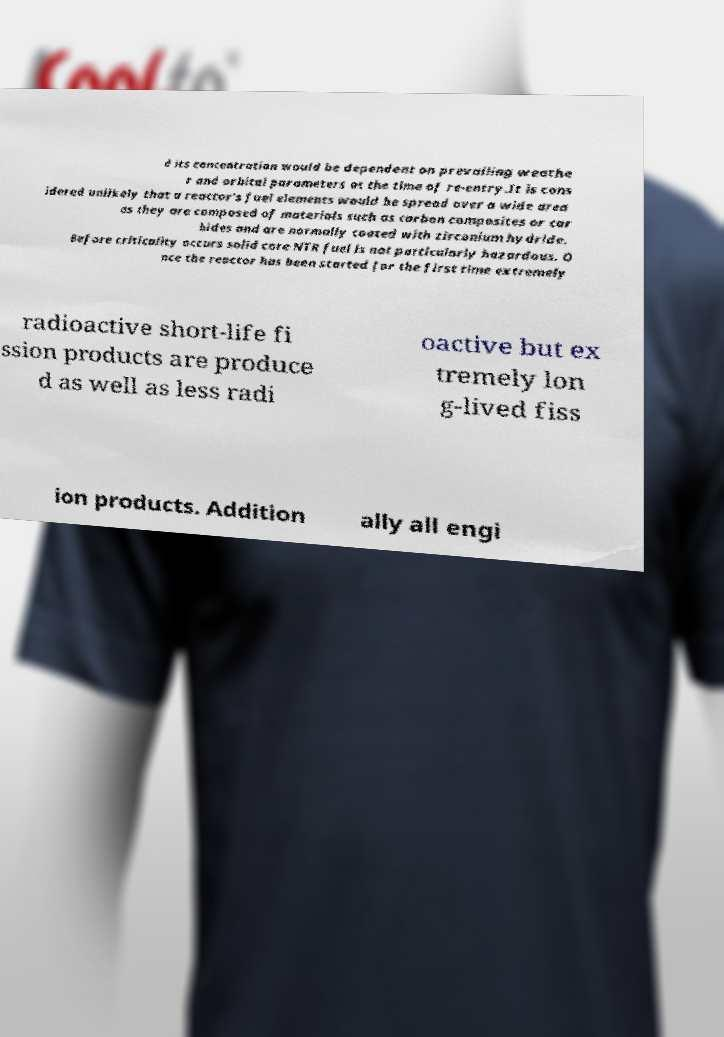Can you accurately transcribe the text from the provided image for me? d its concentration would be dependent on prevailing weathe r and orbital parameters at the time of re-entry.It is cons idered unlikely that a reactor's fuel elements would be spread over a wide area as they are composed of materials such as carbon composites or car bides and are normally coated with zirconium hydride. Before criticality occurs solid core NTR fuel is not particularly hazardous. O nce the reactor has been started for the first time extremely radioactive short-life fi ssion products are produce d as well as less radi oactive but ex tremely lon g-lived fiss ion products. Addition ally all engi 